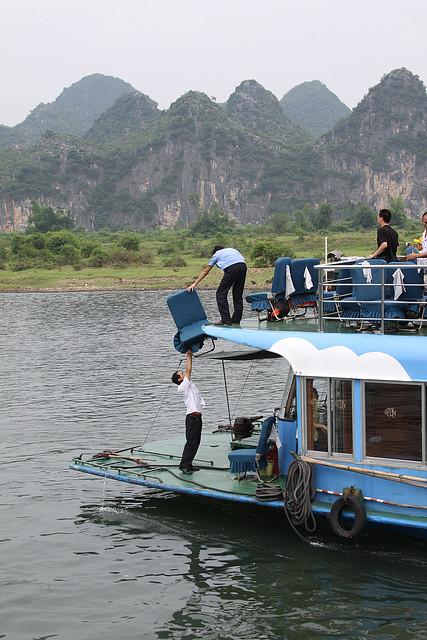What is the man putting on his head?
Quick response, please. Chair. What is on the background?
Keep it brief. Mountains. Are there any people in the image?
Quick response, please. Yes. What type of boat is this?
Write a very short answer. Ferry. What color is the water?
Write a very short answer. Blue. What is being handed to the person on the lower level?
Be succinct. Chair. How many people on this boat are visible?
Concise answer only. 4. 